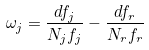<formula> <loc_0><loc_0><loc_500><loc_500>\omega _ { j } = \frac { d f _ { j } } { N _ { j } f _ { j } } - \frac { d f _ { r } } { N _ { r } f _ { r } }</formula> 